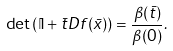Convert formula to latex. <formula><loc_0><loc_0><loc_500><loc_500>\det { \left ( \mathbb { I } + \bar { t } D f ( \bar { x } ) \right ) } = \frac { \beta ( \bar { t } ) } { \beta ( 0 ) } .</formula> 